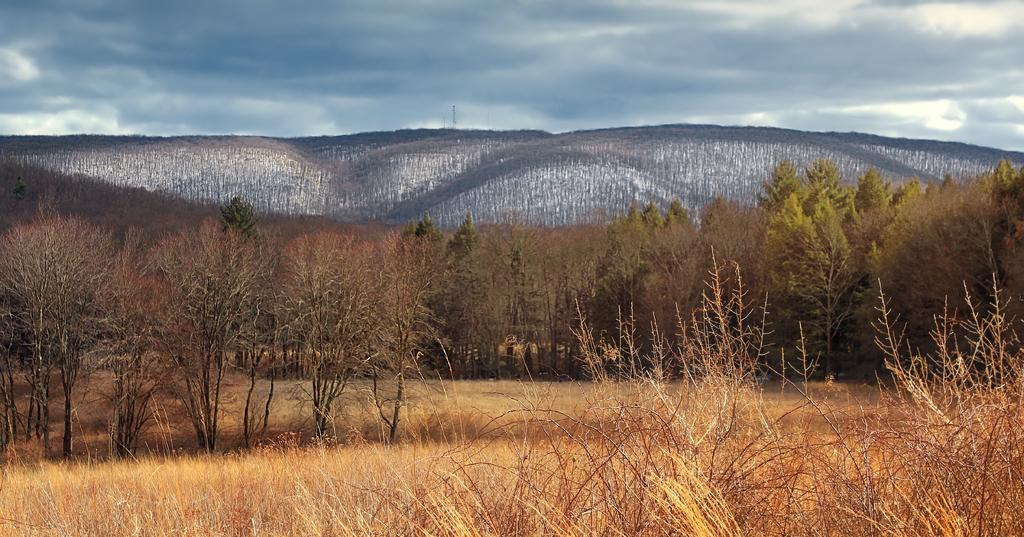What type of natural elements can be seen in the image? There are trees and mountains in the image. What part of the natural environment is visible in the image? The sky is visible in the image. How many roses can be seen growing on the mountains in the image? There are no roses visible in the image; it features trees, mountains, and the sky. What type of spark can be seen coming from the trees in the image? There is no spark present in the image; it features trees, mountains, and the sky. 